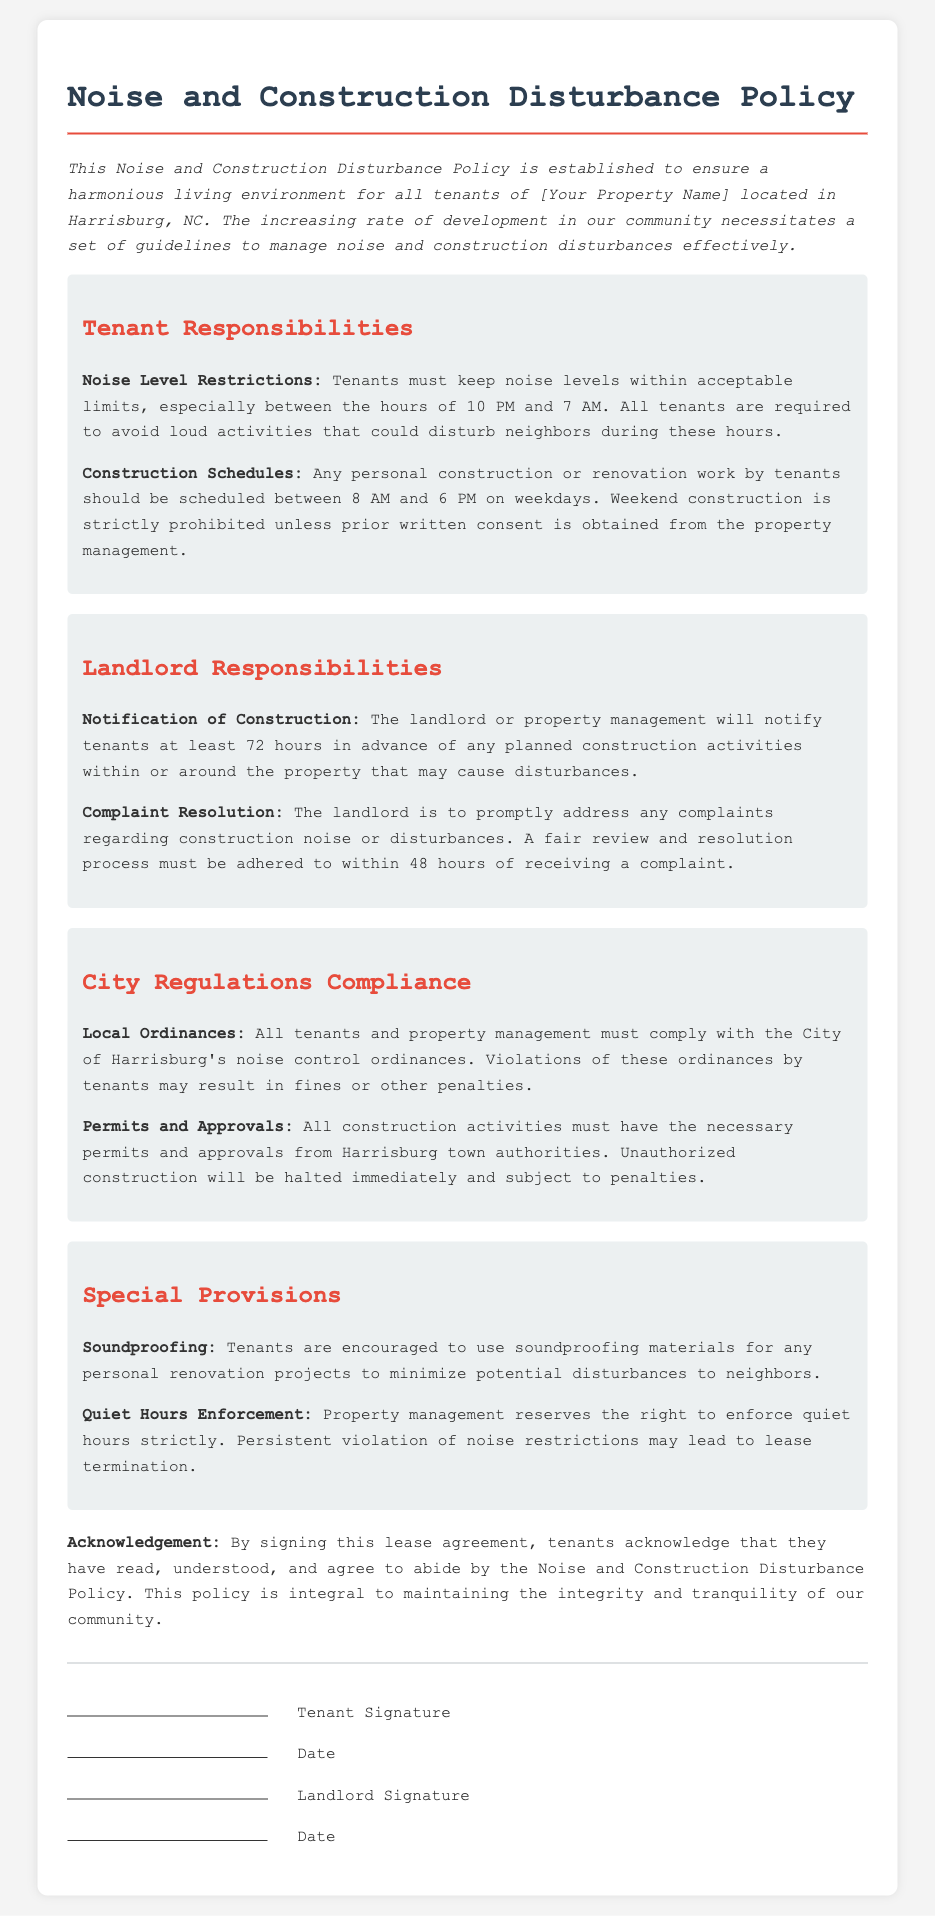what are the quiet hours? Quiet hours are the hours when noise levels must be kept within acceptable limits, specifically between 10 PM and 7 AM.
Answer: 10 PM and 7 AM what is the construction schedule for tenants? The construction schedule for tenants states that any personal construction or renovation work should be scheduled between 8 AM and 6 PM on weekdays.
Answer: 8 AM and 6 PM on weekdays how many hours in advance must tenants be notified of planned construction? Tenants must be notified at least 72 hours in advance of any planned construction activities that may cause disturbances.
Answer: 72 hours what is the consequence for persistent violation of noise restrictions? The document states that persistent violation of noise restrictions may lead to lease termination.
Answer: Lease termination what soundproofing measures are encouraged? The policy encourages tenants to use soundproofing materials for personal renovation projects to minimize disturbances.
Answer: Soundproofing materials 